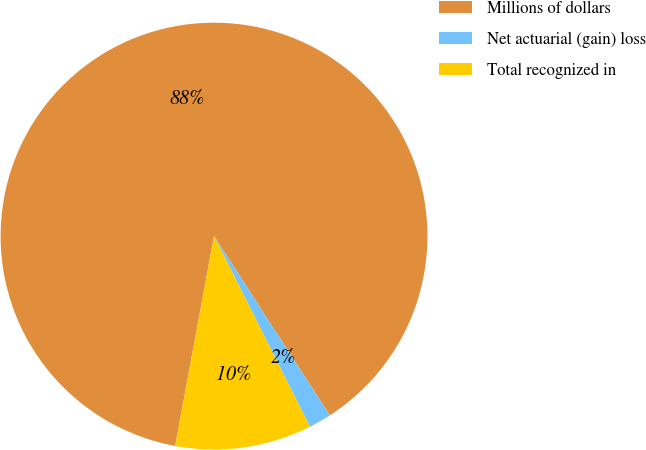Convert chart to OTSL. <chart><loc_0><loc_0><loc_500><loc_500><pie_chart><fcel>Millions of dollars<fcel>Net actuarial (gain) loss<fcel>Total recognized in<nl><fcel>87.96%<fcel>1.71%<fcel>10.33%<nl></chart> 